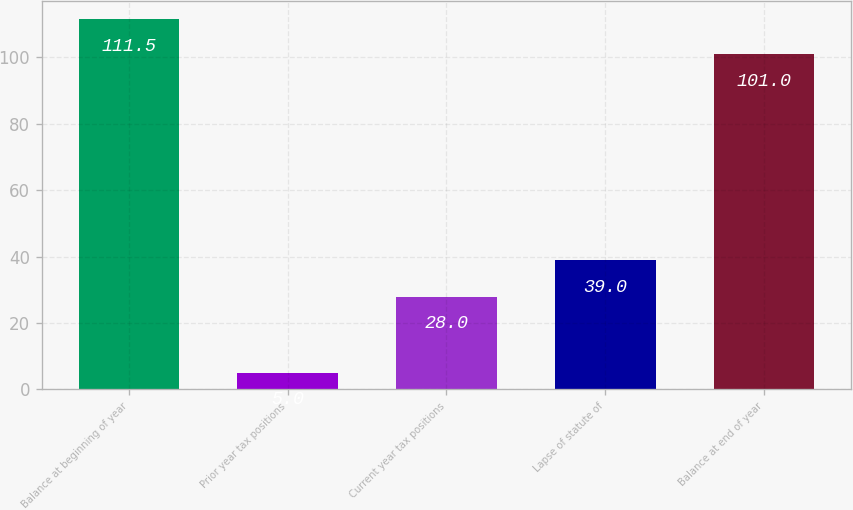Convert chart to OTSL. <chart><loc_0><loc_0><loc_500><loc_500><bar_chart><fcel>Balance at beginning of year<fcel>Prior year tax positions<fcel>Current year tax positions<fcel>Lapse of statute of<fcel>Balance at end of year<nl><fcel>111.5<fcel>5<fcel>28<fcel>39<fcel>101<nl></chart> 